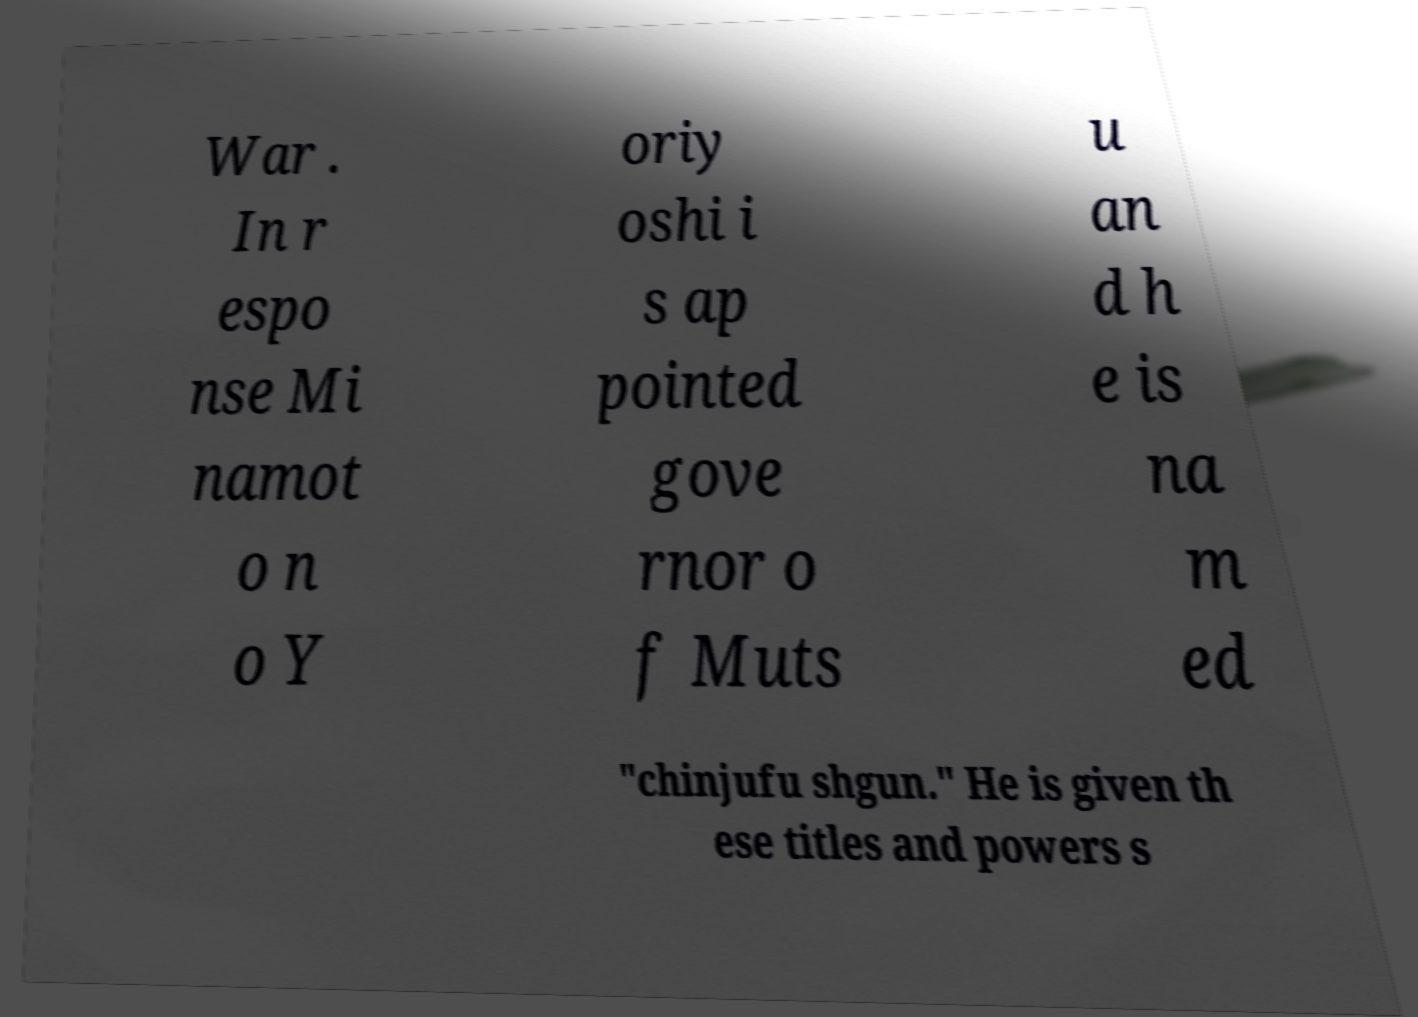Can you accurately transcribe the text from the provided image for me? War . In r espo nse Mi namot o n o Y oriy oshi i s ap pointed gove rnor o f Muts u an d h e is na m ed "chinjufu shgun." He is given th ese titles and powers s 